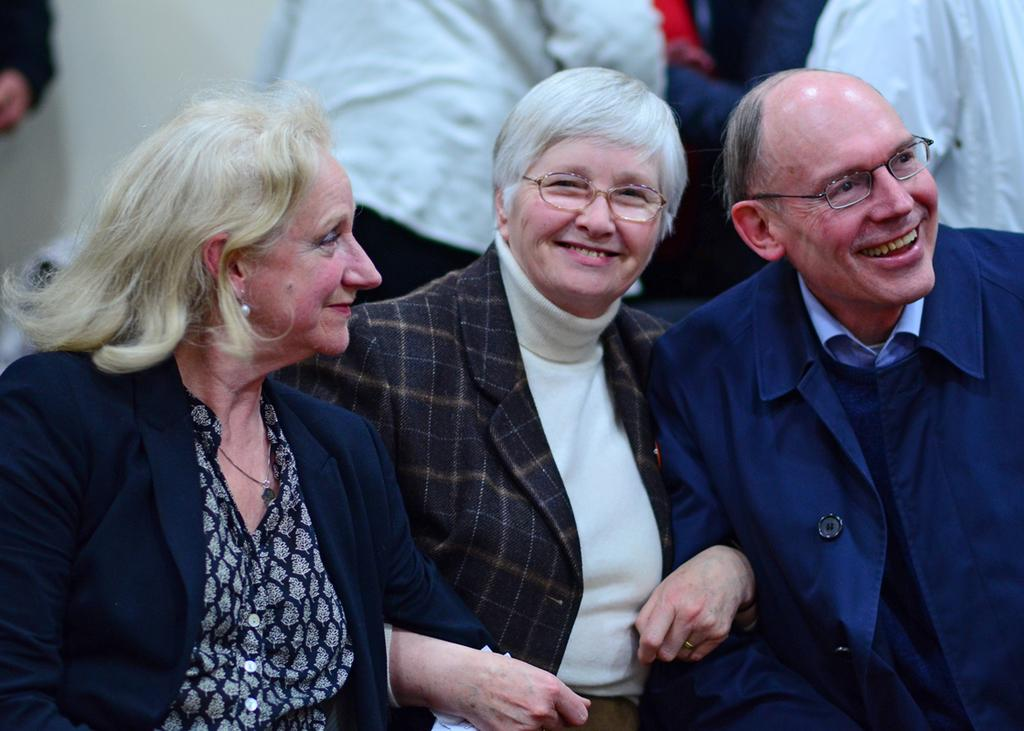How many individuals are present in the image? There are many people in the image. Can you describe any specific features of some of the people? Some of the people are wearing glasses. What can be seen in the background of the image? There is a wall in the background of the image. How many twigs are being held by the people in the image? There are no twigs present in the image. Can you tell me how many rabbits are visible in the image? There are no rabbits present in the image. 